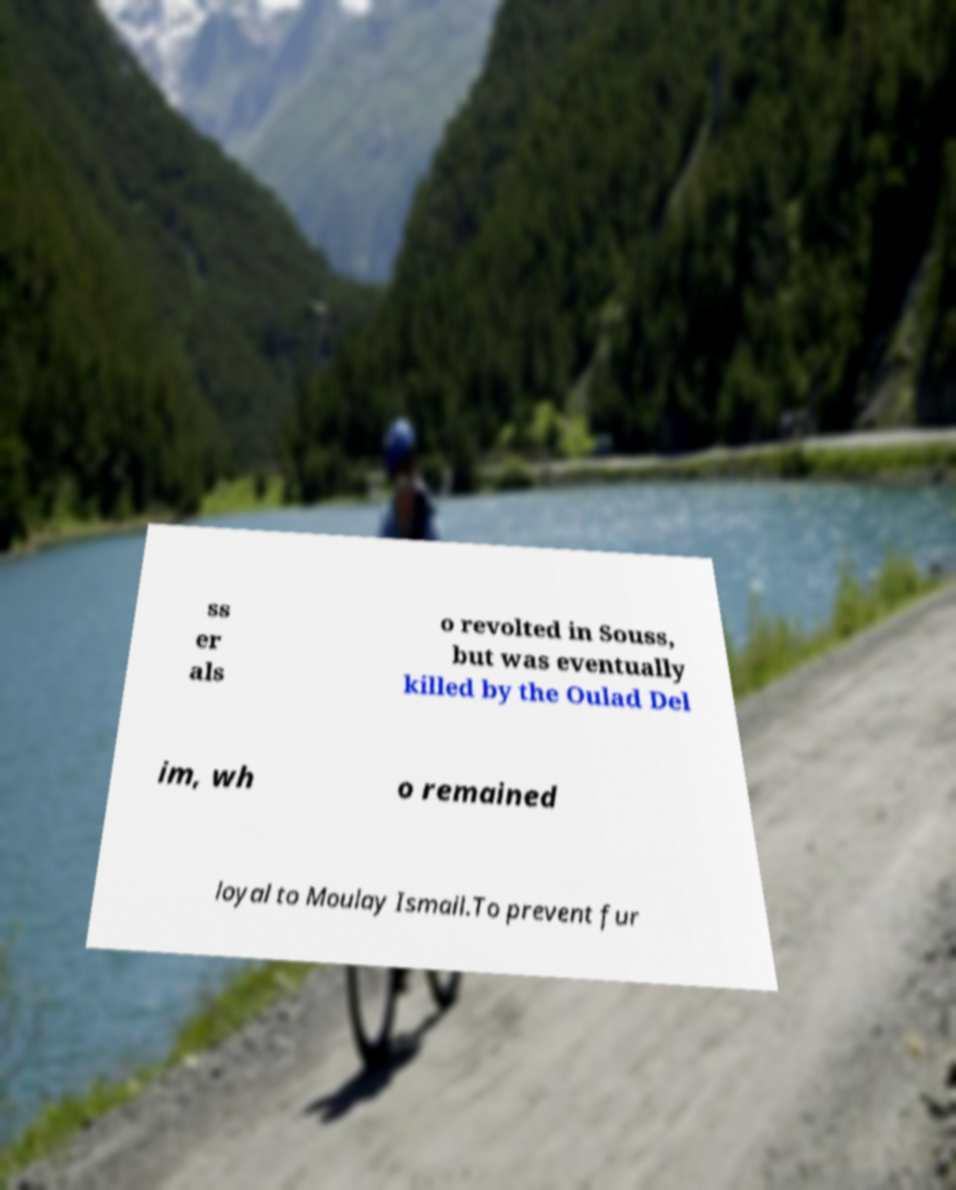For documentation purposes, I need the text within this image transcribed. Could you provide that? ss er als o revolted in Souss, but was eventually killed by the Oulad Del im, wh o remained loyal to Moulay Ismail.To prevent fur 